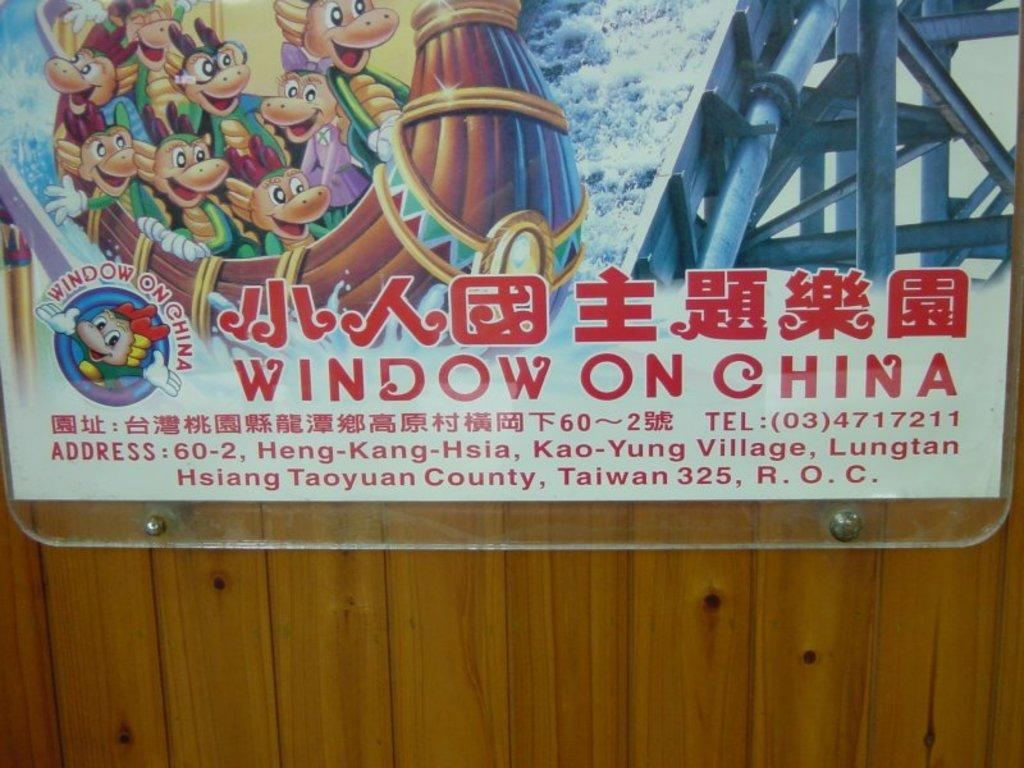<image>
Describe the image concisely. Sign on a wall that says Window on China. 